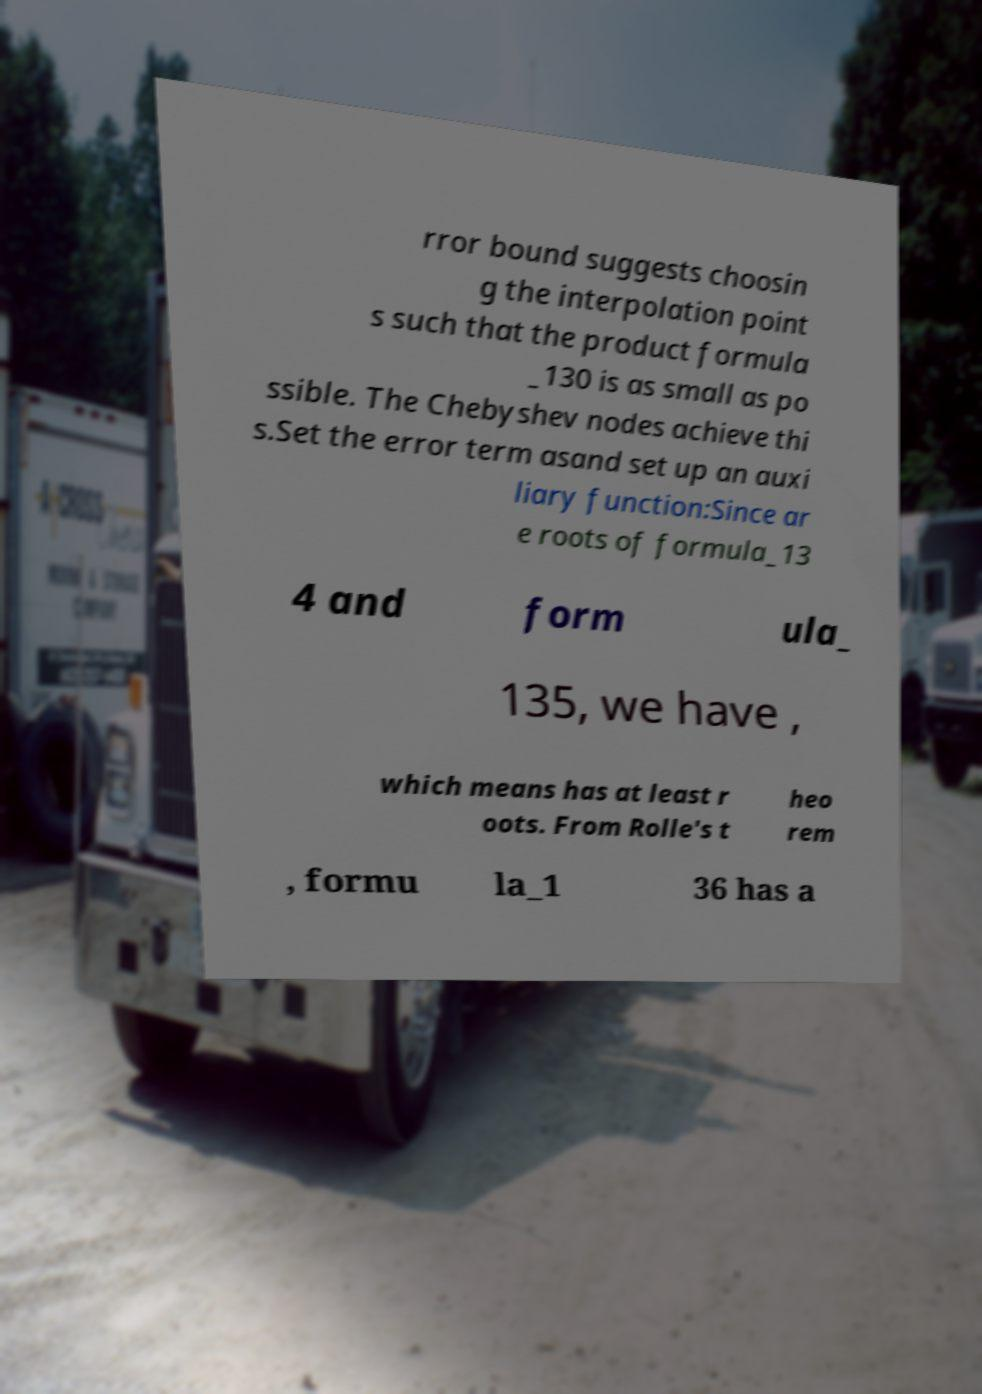What messages or text are displayed in this image? I need them in a readable, typed format. rror bound suggests choosin g the interpolation point s such that the product formula _130 is as small as po ssible. The Chebyshev nodes achieve thi s.Set the error term asand set up an auxi liary function:Since ar e roots of formula_13 4 and form ula_ 135, we have , which means has at least r oots. From Rolle's t heo rem , formu la_1 36 has a 